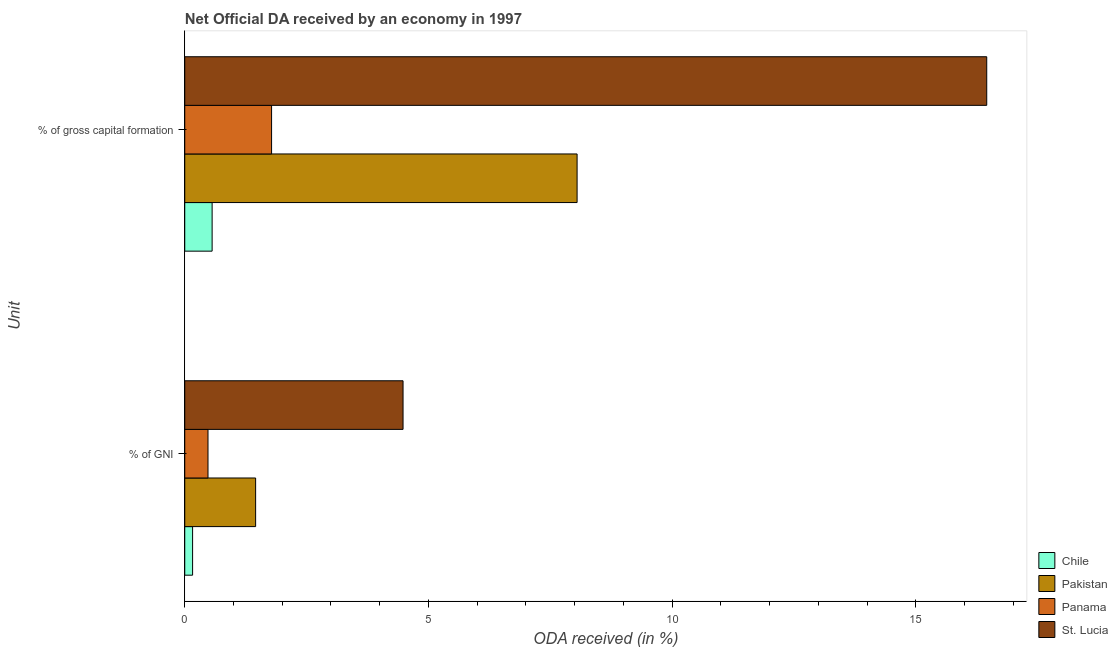How many different coloured bars are there?
Offer a terse response. 4. Are the number of bars on each tick of the Y-axis equal?
Offer a very short reply. Yes. What is the label of the 1st group of bars from the top?
Offer a terse response. % of gross capital formation. What is the oda received as percentage of gni in Chile?
Ensure brevity in your answer.  0.16. Across all countries, what is the maximum oda received as percentage of gross capital formation?
Provide a short and direct response. 16.46. Across all countries, what is the minimum oda received as percentage of gross capital formation?
Ensure brevity in your answer.  0.56. In which country was the oda received as percentage of gni maximum?
Make the answer very short. St. Lucia. What is the total oda received as percentage of gni in the graph?
Offer a terse response. 6.57. What is the difference between the oda received as percentage of gross capital formation in Pakistan and that in St. Lucia?
Ensure brevity in your answer.  -8.41. What is the difference between the oda received as percentage of gross capital formation in Pakistan and the oda received as percentage of gni in St. Lucia?
Keep it short and to the point. 3.57. What is the average oda received as percentage of gni per country?
Keep it short and to the point. 1.64. What is the difference between the oda received as percentage of gni and oda received as percentage of gross capital formation in Chile?
Provide a short and direct response. -0.4. In how many countries, is the oda received as percentage of gross capital formation greater than 3 %?
Keep it short and to the point. 2. What is the ratio of the oda received as percentage of gni in Pakistan to that in St. Lucia?
Provide a short and direct response. 0.32. Is the oda received as percentage of gross capital formation in Chile less than that in St. Lucia?
Your response must be concise. Yes. In how many countries, is the oda received as percentage of gni greater than the average oda received as percentage of gni taken over all countries?
Offer a very short reply. 1. What does the 2nd bar from the bottom in % of GNI represents?
Your answer should be compact. Pakistan. How many countries are there in the graph?
Give a very brief answer. 4. What is the difference between two consecutive major ticks on the X-axis?
Your answer should be compact. 5. Are the values on the major ticks of X-axis written in scientific E-notation?
Your response must be concise. No. Does the graph contain any zero values?
Give a very brief answer. No. Does the graph contain grids?
Your answer should be compact. No. How many legend labels are there?
Your answer should be very brief. 4. How are the legend labels stacked?
Your response must be concise. Vertical. What is the title of the graph?
Offer a terse response. Net Official DA received by an economy in 1997. Does "Sri Lanka" appear as one of the legend labels in the graph?
Give a very brief answer. No. What is the label or title of the X-axis?
Provide a succinct answer. ODA received (in %). What is the label or title of the Y-axis?
Provide a succinct answer. Unit. What is the ODA received (in %) of Chile in % of GNI?
Provide a short and direct response. 0.16. What is the ODA received (in %) of Pakistan in % of GNI?
Make the answer very short. 1.45. What is the ODA received (in %) in Panama in % of GNI?
Offer a very short reply. 0.48. What is the ODA received (in %) of St. Lucia in % of GNI?
Provide a short and direct response. 4.48. What is the ODA received (in %) of Chile in % of gross capital formation?
Your answer should be very brief. 0.56. What is the ODA received (in %) in Pakistan in % of gross capital formation?
Your answer should be compact. 8.05. What is the ODA received (in %) of Panama in % of gross capital formation?
Make the answer very short. 1.78. What is the ODA received (in %) in St. Lucia in % of gross capital formation?
Make the answer very short. 16.46. Across all Unit, what is the maximum ODA received (in %) in Chile?
Give a very brief answer. 0.56. Across all Unit, what is the maximum ODA received (in %) in Pakistan?
Provide a succinct answer. 8.05. Across all Unit, what is the maximum ODA received (in %) in Panama?
Your response must be concise. 1.78. Across all Unit, what is the maximum ODA received (in %) in St. Lucia?
Your answer should be compact. 16.46. Across all Unit, what is the minimum ODA received (in %) of Chile?
Your answer should be very brief. 0.16. Across all Unit, what is the minimum ODA received (in %) in Pakistan?
Ensure brevity in your answer.  1.45. Across all Unit, what is the minimum ODA received (in %) in Panama?
Your answer should be compact. 0.48. Across all Unit, what is the minimum ODA received (in %) of St. Lucia?
Your answer should be very brief. 4.48. What is the total ODA received (in %) of Chile in the graph?
Offer a very short reply. 0.72. What is the total ODA received (in %) in Pakistan in the graph?
Offer a terse response. 9.51. What is the total ODA received (in %) of Panama in the graph?
Your answer should be very brief. 2.26. What is the total ODA received (in %) of St. Lucia in the graph?
Your response must be concise. 20.94. What is the difference between the ODA received (in %) of Chile in % of GNI and that in % of gross capital formation?
Provide a succinct answer. -0.4. What is the difference between the ODA received (in %) of Pakistan in % of GNI and that in % of gross capital formation?
Your answer should be very brief. -6.6. What is the difference between the ODA received (in %) in Panama in % of GNI and that in % of gross capital formation?
Your response must be concise. -1.3. What is the difference between the ODA received (in %) of St. Lucia in % of GNI and that in % of gross capital formation?
Provide a succinct answer. -11.98. What is the difference between the ODA received (in %) of Chile in % of GNI and the ODA received (in %) of Pakistan in % of gross capital formation?
Your answer should be compact. -7.89. What is the difference between the ODA received (in %) in Chile in % of GNI and the ODA received (in %) in Panama in % of gross capital formation?
Ensure brevity in your answer.  -1.62. What is the difference between the ODA received (in %) in Chile in % of GNI and the ODA received (in %) in St. Lucia in % of gross capital formation?
Your answer should be compact. -16.3. What is the difference between the ODA received (in %) of Pakistan in % of GNI and the ODA received (in %) of Panama in % of gross capital formation?
Offer a terse response. -0.33. What is the difference between the ODA received (in %) in Pakistan in % of GNI and the ODA received (in %) in St. Lucia in % of gross capital formation?
Your answer should be compact. -15. What is the difference between the ODA received (in %) in Panama in % of GNI and the ODA received (in %) in St. Lucia in % of gross capital formation?
Provide a short and direct response. -15.98. What is the average ODA received (in %) in Chile per Unit?
Provide a short and direct response. 0.36. What is the average ODA received (in %) in Pakistan per Unit?
Provide a succinct answer. 4.75. What is the average ODA received (in %) in Panama per Unit?
Your response must be concise. 1.13. What is the average ODA received (in %) of St. Lucia per Unit?
Your response must be concise. 10.47. What is the difference between the ODA received (in %) of Chile and ODA received (in %) of Pakistan in % of GNI?
Provide a short and direct response. -1.29. What is the difference between the ODA received (in %) in Chile and ODA received (in %) in Panama in % of GNI?
Give a very brief answer. -0.32. What is the difference between the ODA received (in %) of Chile and ODA received (in %) of St. Lucia in % of GNI?
Your answer should be very brief. -4.32. What is the difference between the ODA received (in %) of Pakistan and ODA received (in %) of Panama in % of GNI?
Ensure brevity in your answer.  0.98. What is the difference between the ODA received (in %) of Pakistan and ODA received (in %) of St. Lucia in % of GNI?
Ensure brevity in your answer.  -3.03. What is the difference between the ODA received (in %) of Panama and ODA received (in %) of St. Lucia in % of GNI?
Ensure brevity in your answer.  -4. What is the difference between the ODA received (in %) in Chile and ODA received (in %) in Pakistan in % of gross capital formation?
Provide a succinct answer. -7.49. What is the difference between the ODA received (in %) in Chile and ODA received (in %) in Panama in % of gross capital formation?
Offer a very short reply. -1.22. What is the difference between the ODA received (in %) in Chile and ODA received (in %) in St. Lucia in % of gross capital formation?
Your answer should be very brief. -15.9. What is the difference between the ODA received (in %) in Pakistan and ODA received (in %) in Panama in % of gross capital formation?
Give a very brief answer. 6.27. What is the difference between the ODA received (in %) of Pakistan and ODA received (in %) of St. Lucia in % of gross capital formation?
Your answer should be compact. -8.41. What is the difference between the ODA received (in %) in Panama and ODA received (in %) in St. Lucia in % of gross capital formation?
Provide a short and direct response. -14.68. What is the ratio of the ODA received (in %) of Chile in % of GNI to that in % of gross capital formation?
Offer a very short reply. 0.29. What is the ratio of the ODA received (in %) in Pakistan in % of GNI to that in % of gross capital formation?
Ensure brevity in your answer.  0.18. What is the ratio of the ODA received (in %) of Panama in % of GNI to that in % of gross capital formation?
Your answer should be very brief. 0.27. What is the ratio of the ODA received (in %) of St. Lucia in % of GNI to that in % of gross capital formation?
Ensure brevity in your answer.  0.27. What is the difference between the highest and the second highest ODA received (in %) in Chile?
Ensure brevity in your answer.  0.4. What is the difference between the highest and the second highest ODA received (in %) of Pakistan?
Keep it short and to the point. 6.6. What is the difference between the highest and the second highest ODA received (in %) of Panama?
Ensure brevity in your answer.  1.3. What is the difference between the highest and the second highest ODA received (in %) of St. Lucia?
Offer a very short reply. 11.98. What is the difference between the highest and the lowest ODA received (in %) of Chile?
Your answer should be very brief. 0.4. What is the difference between the highest and the lowest ODA received (in %) of Pakistan?
Your response must be concise. 6.6. What is the difference between the highest and the lowest ODA received (in %) in Panama?
Offer a terse response. 1.3. What is the difference between the highest and the lowest ODA received (in %) in St. Lucia?
Provide a short and direct response. 11.98. 